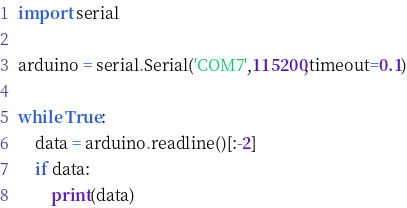Convert code to text. <code><loc_0><loc_0><loc_500><loc_500><_Python_>import serial

arduino = serial.Serial('COM7',115200,timeout=0.1)

while True:
	data = arduino.readline()[:-2]
	if data:
		print(data)
</code> 